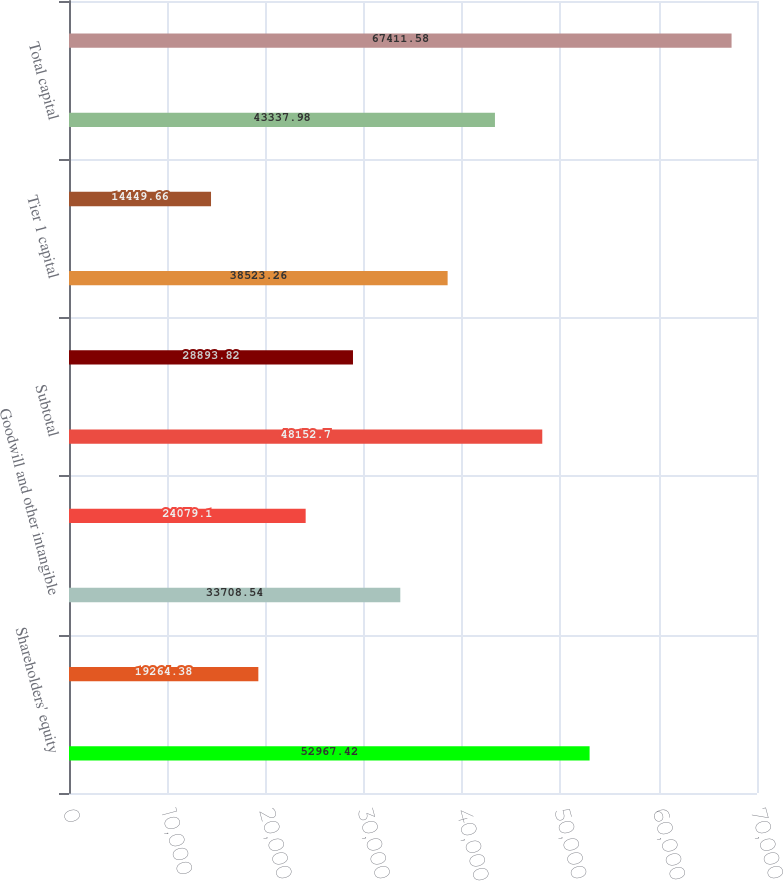Convert chart to OTSL. <chart><loc_0><loc_0><loc_500><loc_500><bar_chart><fcel>Shareholders' equity<fcel>Losses in other comprehensive<fcel>Goodwill and other intangible<fcel>Qualifying restricted core<fcel>Subtotal<fcel>Disallowed servicing assets<fcel>Tier 1 capital<fcel>Allowable allowance for loan<fcel>Total capital<fcel>Total average assets<nl><fcel>52967.4<fcel>19264.4<fcel>33708.5<fcel>24079.1<fcel>48152.7<fcel>28893.8<fcel>38523.3<fcel>14449.7<fcel>43338<fcel>67411.6<nl></chart> 